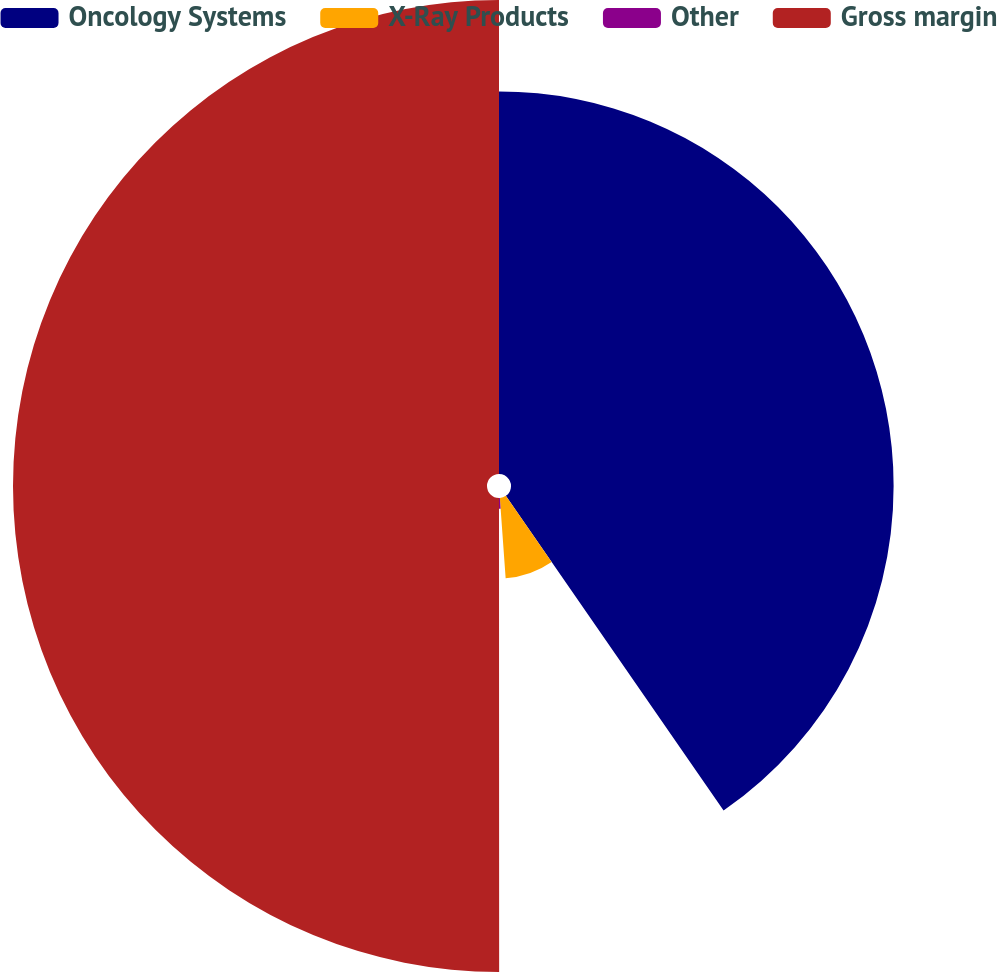Convert chart to OTSL. <chart><loc_0><loc_0><loc_500><loc_500><pie_chart><fcel>Oncology Systems<fcel>X-Ray Products<fcel>Other<fcel>Gross margin<nl><fcel>40.36%<fcel>8.49%<fcel>1.14%<fcel>50.0%<nl></chart> 